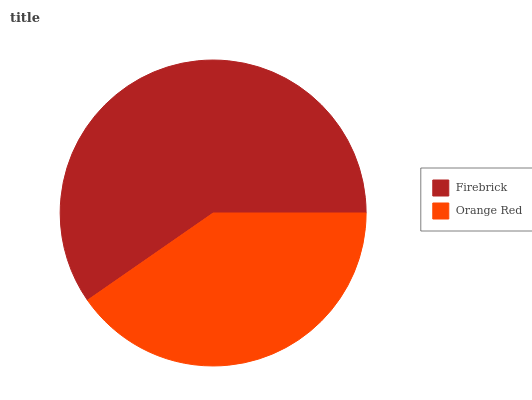Is Orange Red the minimum?
Answer yes or no. Yes. Is Firebrick the maximum?
Answer yes or no. Yes. Is Orange Red the maximum?
Answer yes or no. No. Is Firebrick greater than Orange Red?
Answer yes or no. Yes. Is Orange Red less than Firebrick?
Answer yes or no. Yes. Is Orange Red greater than Firebrick?
Answer yes or no. No. Is Firebrick less than Orange Red?
Answer yes or no. No. Is Firebrick the high median?
Answer yes or no. Yes. Is Orange Red the low median?
Answer yes or no. Yes. Is Orange Red the high median?
Answer yes or no. No. Is Firebrick the low median?
Answer yes or no. No. 